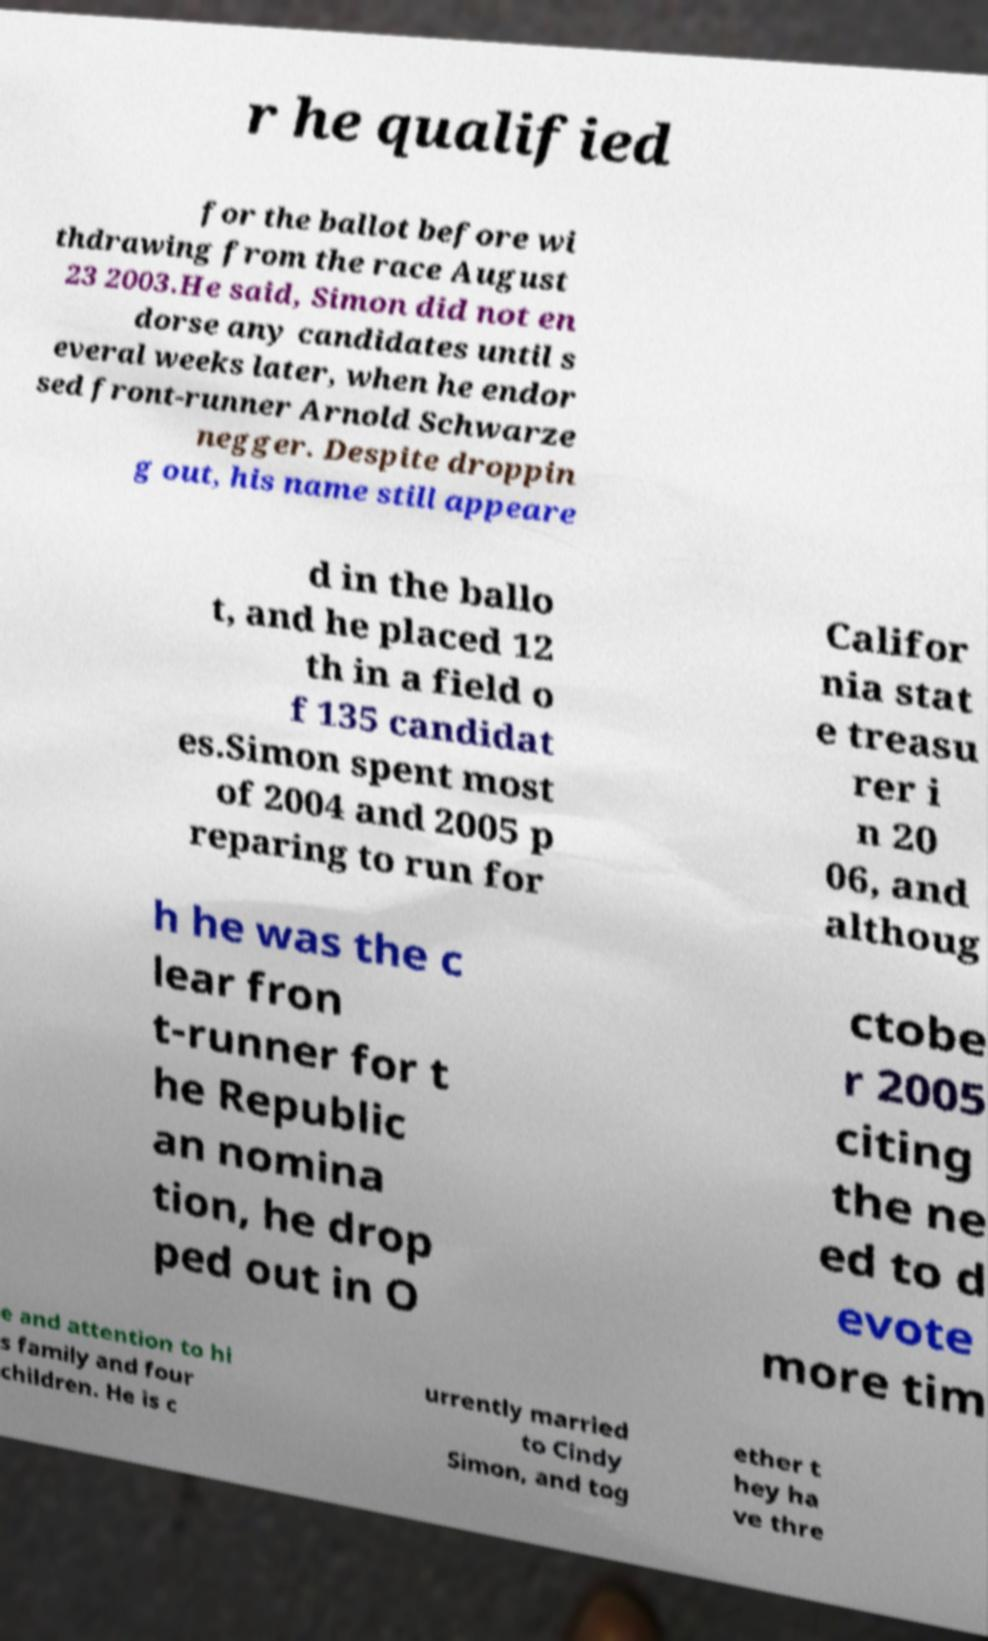Please identify and transcribe the text found in this image. r he qualified for the ballot before wi thdrawing from the race August 23 2003.He said, Simon did not en dorse any candidates until s everal weeks later, when he endor sed front-runner Arnold Schwarze negger. Despite droppin g out, his name still appeare d in the ballo t, and he placed 12 th in a field o f 135 candidat es.Simon spent most of 2004 and 2005 p reparing to run for Califor nia stat e treasu rer i n 20 06, and althoug h he was the c lear fron t-runner for t he Republic an nomina tion, he drop ped out in O ctobe r 2005 citing the ne ed to d evote more tim e and attention to hi s family and four children. He is c urrently married to Cindy Simon, and tog ether t hey ha ve thre 